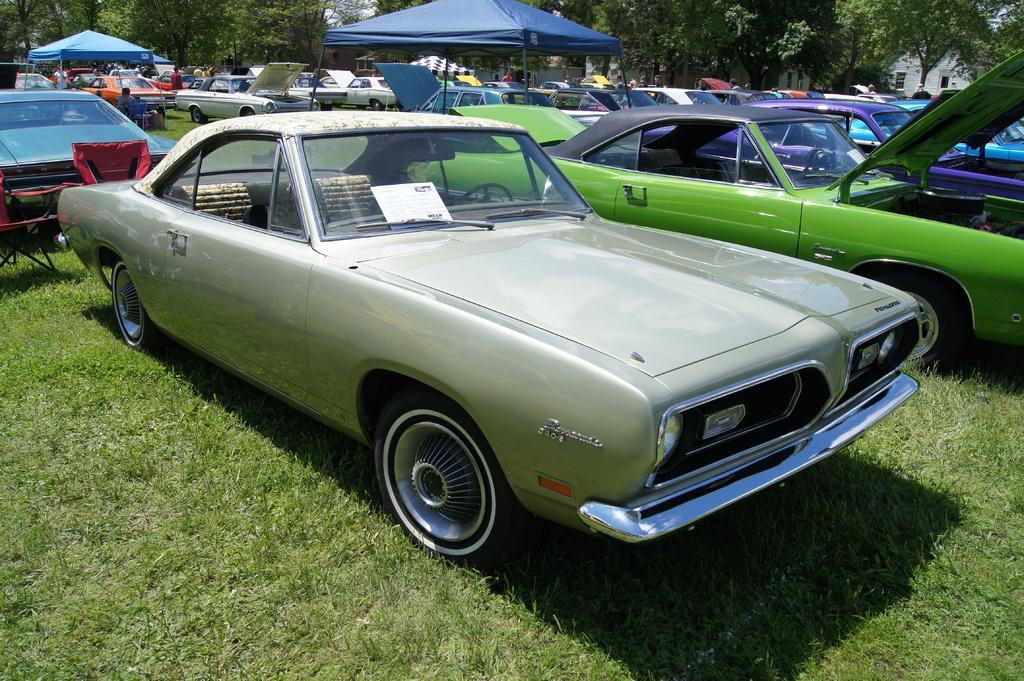Could you give a brief overview of what you see in this image? In this image we can see motor vehicles on the ground, tents, trees, buildings and persons standing. 